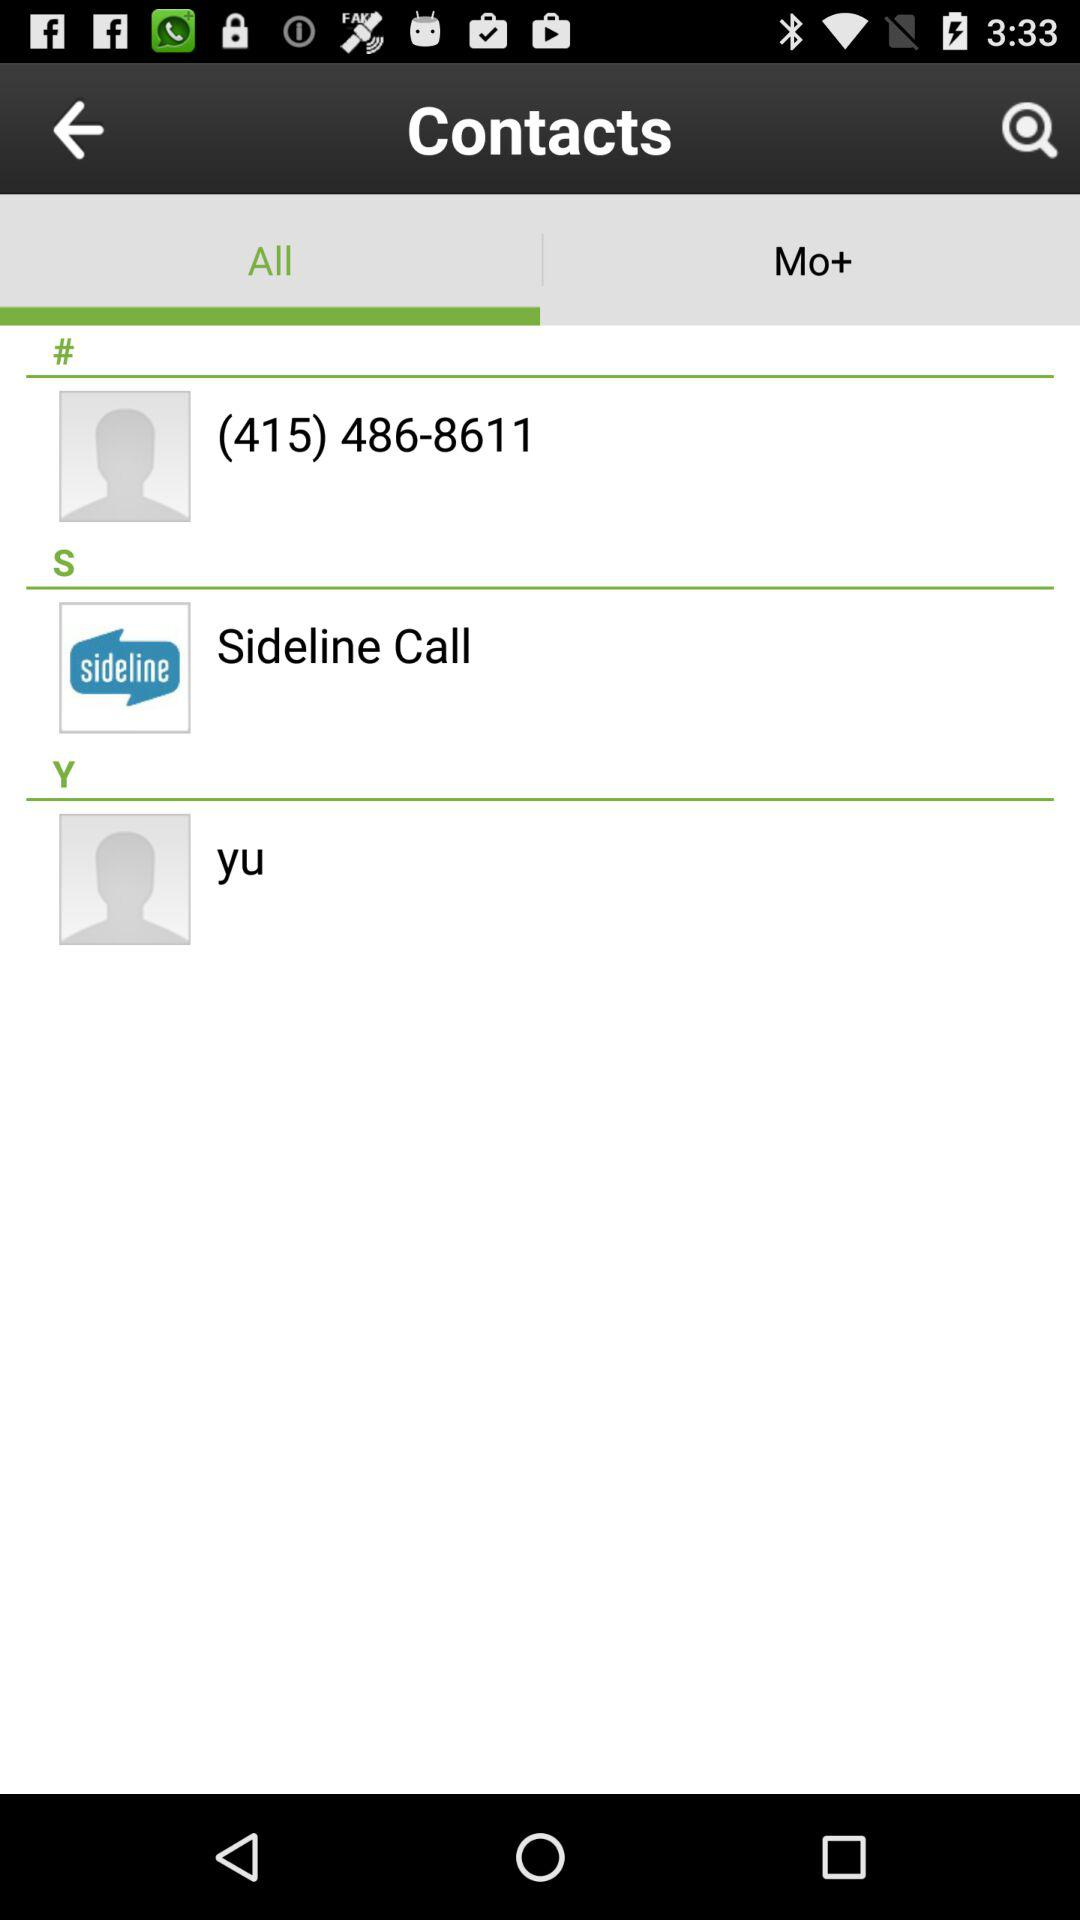Which tab is selected? The selected tab is "All". 